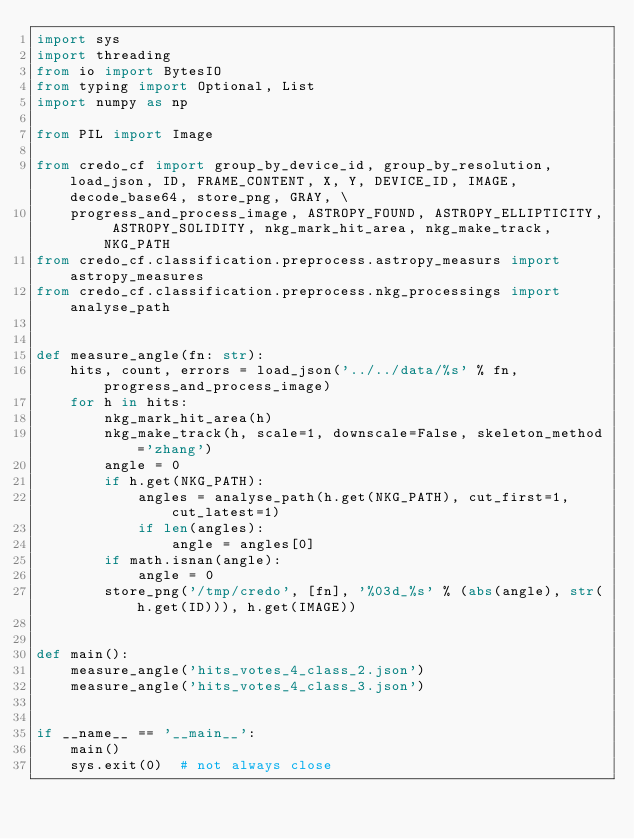<code> <loc_0><loc_0><loc_500><loc_500><_Python_>import sys
import threading
from io import BytesIO
from typing import Optional, List
import numpy as np

from PIL import Image

from credo_cf import group_by_device_id, group_by_resolution, load_json, ID, FRAME_CONTENT, X, Y, DEVICE_ID, IMAGE, decode_base64, store_png, GRAY, \
    progress_and_process_image, ASTROPY_FOUND, ASTROPY_ELLIPTICITY, ASTROPY_SOLIDITY, nkg_mark_hit_area, nkg_make_track, NKG_PATH
from credo_cf.classification.preprocess.astropy_measurs import astropy_measures
from credo_cf.classification.preprocess.nkg_processings import analyse_path


def measure_angle(fn: str):
    hits, count, errors = load_json('../../data/%s' % fn, progress_and_process_image)
    for h in hits:
        nkg_mark_hit_area(h)
        nkg_make_track(h, scale=1, downscale=False, skeleton_method='zhang')
        angle = 0
        if h.get(NKG_PATH):
            angles = analyse_path(h.get(NKG_PATH), cut_first=1, cut_latest=1)
            if len(angles):
                angle = angles[0]
        if math.isnan(angle):
            angle = 0
        store_png('/tmp/credo', [fn], '%03d_%s' % (abs(angle), str(h.get(ID))), h.get(IMAGE))


def main():
    measure_angle('hits_votes_4_class_2.json')
    measure_angle('hits_votes_4_class_3.json')


if __name__ == '__main__':
    main()
    sys.exit(0)  # not always close
</code> 